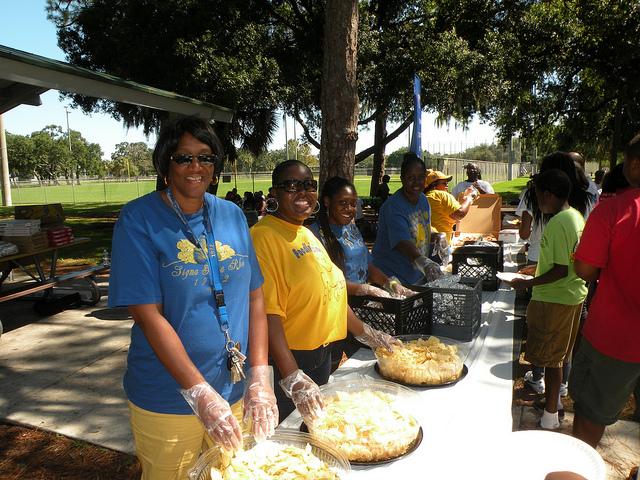Is it sunny?
Write a very short answer. Yes. How many people are wearing sunglasses?
Give a very brief answer. 2. What color lanyard is the person on the left wearing?
Be succinct. Blue. 